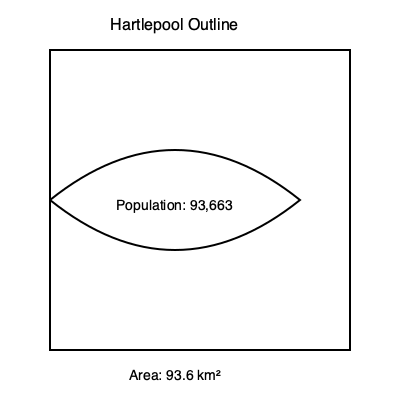As a local podcast host discussing Hartlepool's demographics, you're presented with a simplified outline map of the town. Given that Hartlepool has an area of 93.6 km² and a population of 93,663, calculate the population density. How might this figure impact local election strategies and community development plans? To calculate the population density of Hartlepool, we need to divide the total population by the area. Let's break it down step-by-step:

1. Given information:
   - Area of Hartlepool: 93.6 km²
   - Population: 93,663

2. Population density formula:
   $$ \text{Population Density} = \frac{\text{Total Population}}{\text{Total Area}} $$

3. Plugging in the values:
   $$ \text{Population Density} = \frac{93,663}{93.6 \text{ km²}} $$

4. Calculating:
   $$ \text{Population Density} = 1000.67 \text{ people/km²} $$

5. Rounding to two decimal places:
   $$ \text{Population Density} \approx 1000.67 \text{ people/km²} $$

This population density figure can significantly impact local election strategies and community development plans. A higher density might mean:
- More focus on urban issues like public transportation and housing
- Increased competition for local resources
- Higher potential for door-to-door campaigning
- Greater emphasis on community spaces and services

Understanding this density can help politicians tailor their messages and prioritize certain policies that address the needs of a relatively densely populated area.
Answer: 1000.67 people/km² 